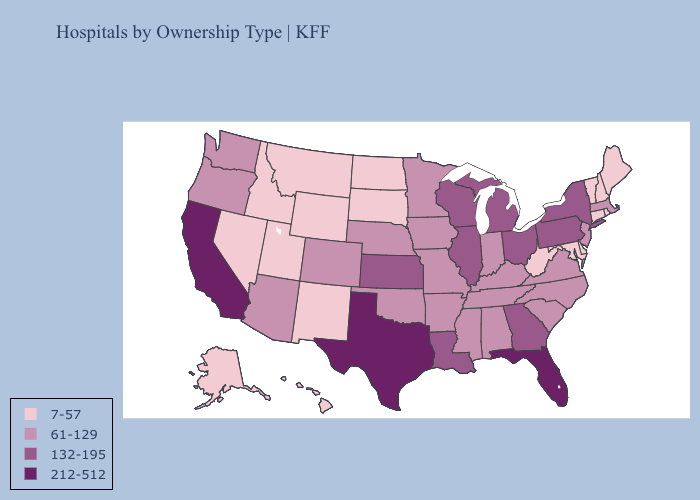Does South Carolina have the lowest value in the USA?
Give a very brief answer. No. Does Pennsylvania have the lowest value in the Northeast?
Write a very short answer. No. Which states have the lowest value in the USA?
Concise answer only. Alaska, Connecticut, Delaware, Hawaii, Idaho, Maine, Maryland, Montana, Nevada, New Hampshire, New Mexico, North Dakota, Rhode Island, South Dakota, Utah, Vermont, West Virginia, Wyoming. What is the lowest value in the West?
Answer briefly. 7-57. Does Alaska have the lowest value in the USA?
Answer briefly. Yes. Name the states that have a value in the range 61-129?
Quick response, please. Alabama, Arizona, Arkansas, Colorado, Indiana, Iowa, Kentucky, Massachusetts, Minnesota, Mississippi, Missouri, Nebraska, New Jersey, North Carolina, Oklahoma, Oregon, South Carolina, Tennessee, Virginia, Washington. What is the highest value in states that border Vermont?
Keep it brief. 132-195. Does Florida have the lowest value in the USA?
Keep it brief. No. What is the value of Utah?
Quick response, please. 7-57. Among the states that border Minnesota , does Wisconsin have the lowest value?
Quick response, please. No. Name the states that have a value in the range 132-195?
Keep it brief. Georgia, Illinois, Kansas, Louisiana, Michigan, New York, Ohio, Pennsylvania, Wisconsin. Name the states that have a value in the range 7-57?
Concise answer only. Alaska, Connecticut, Delaware, Hawaii, Idaho, Maine, Maryland, Montana, Nevada, New Hampshire, New Mexico, North Dakota, Rhode Island, South Dakota, Utah, Vermont, West Virginia, Wyoming. Which states have the lowest value in the USA?
Keep it brief. Alaska, Connecticut, Delaware, Hawaii, Idaho, Maine, Maryland, Montana, Nevada, New Hampshire, New Mexico, North Dakota, Rhode Island, South Dakota, Utah, Vermont, West Virginia, Wyoming. Does the first symbol in the legend represent the smallest category?
Give a very brief answer. Yes. Does Maryland have the lowest value in the South?
Concise answer only. Yes. 